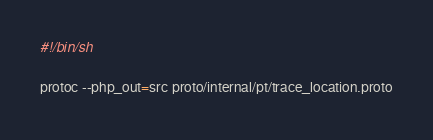<code> <loc_0><loc_0><loc_500><loc_500><_Bash_>#!/bin/sh

protoc --php_out=src proto/internal/pt/trace_location.proto
</code> 